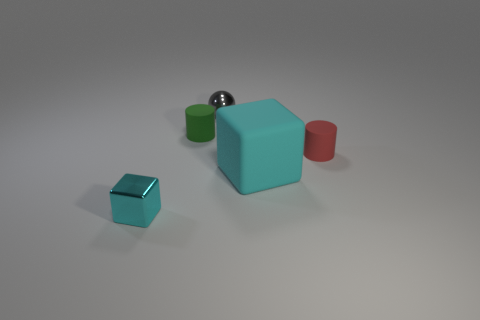What materials do the objects in the image look like they're made of? The objects in the image give the impression of being made from different materials. The cubes and the cylinder have a matte appearance, suggesting that they could be made of colored plastic, while the sphere has a reflective surface that indicates it may be metallic, possibly steel or aluminum. 